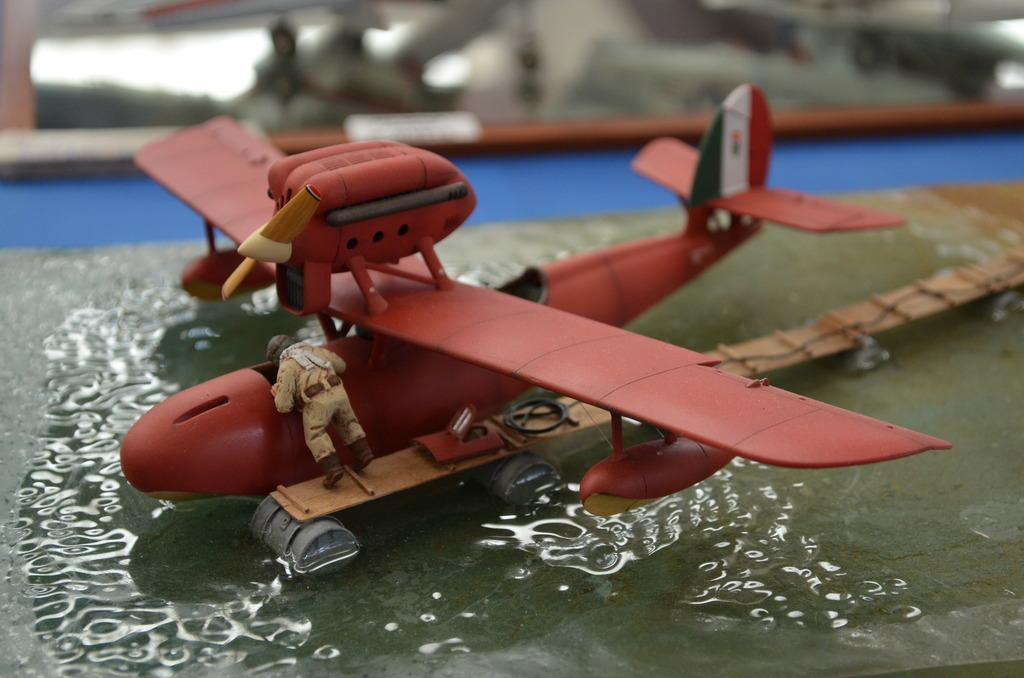What type of toy is depicted in the image? There is a toy of a flying jet and a toy of a person wearing clothes, helmet, and shoes in the image. What can be seen in the background of the image? The background of the image is blurred. Is there any liquid visible in the image? Yes, there is water visible in the image. What type of tray is being used by the person in the image? There is no tray present in the image; it features a toy of a person wearing clothes, helmet, and shoes. Can you tell me how many volleyballs are visible in the image? There are no volleyballs present in the image. 